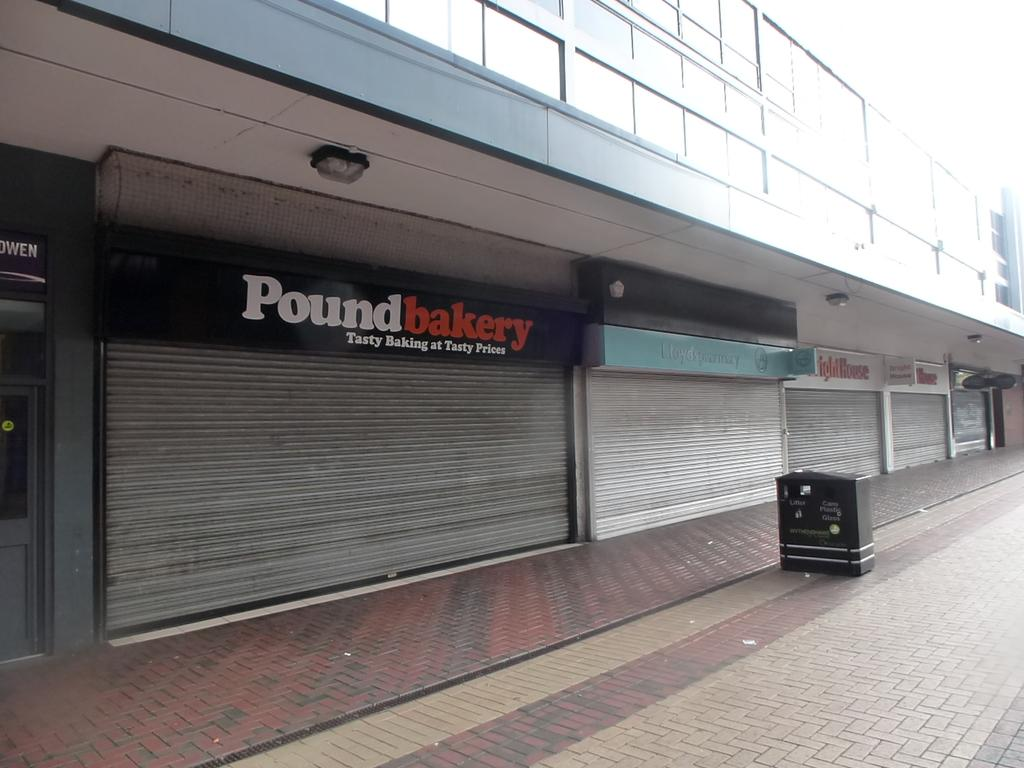Provide a one-sentence caption for the provided image. All the shops are closed including the Pound Bakery. 